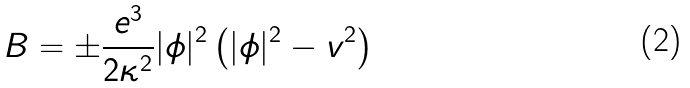Convert formula to latex. <formula><loc_0><loc_0><loc_500><loc_500>B = \pm \frac { e ^ { 3 } } { 2 \kappa ^ { 2 } } | \phi | ^ { 2 } \left ( | \phi | ^ { 2 } - v ^ { 2 } \right )</formula> 